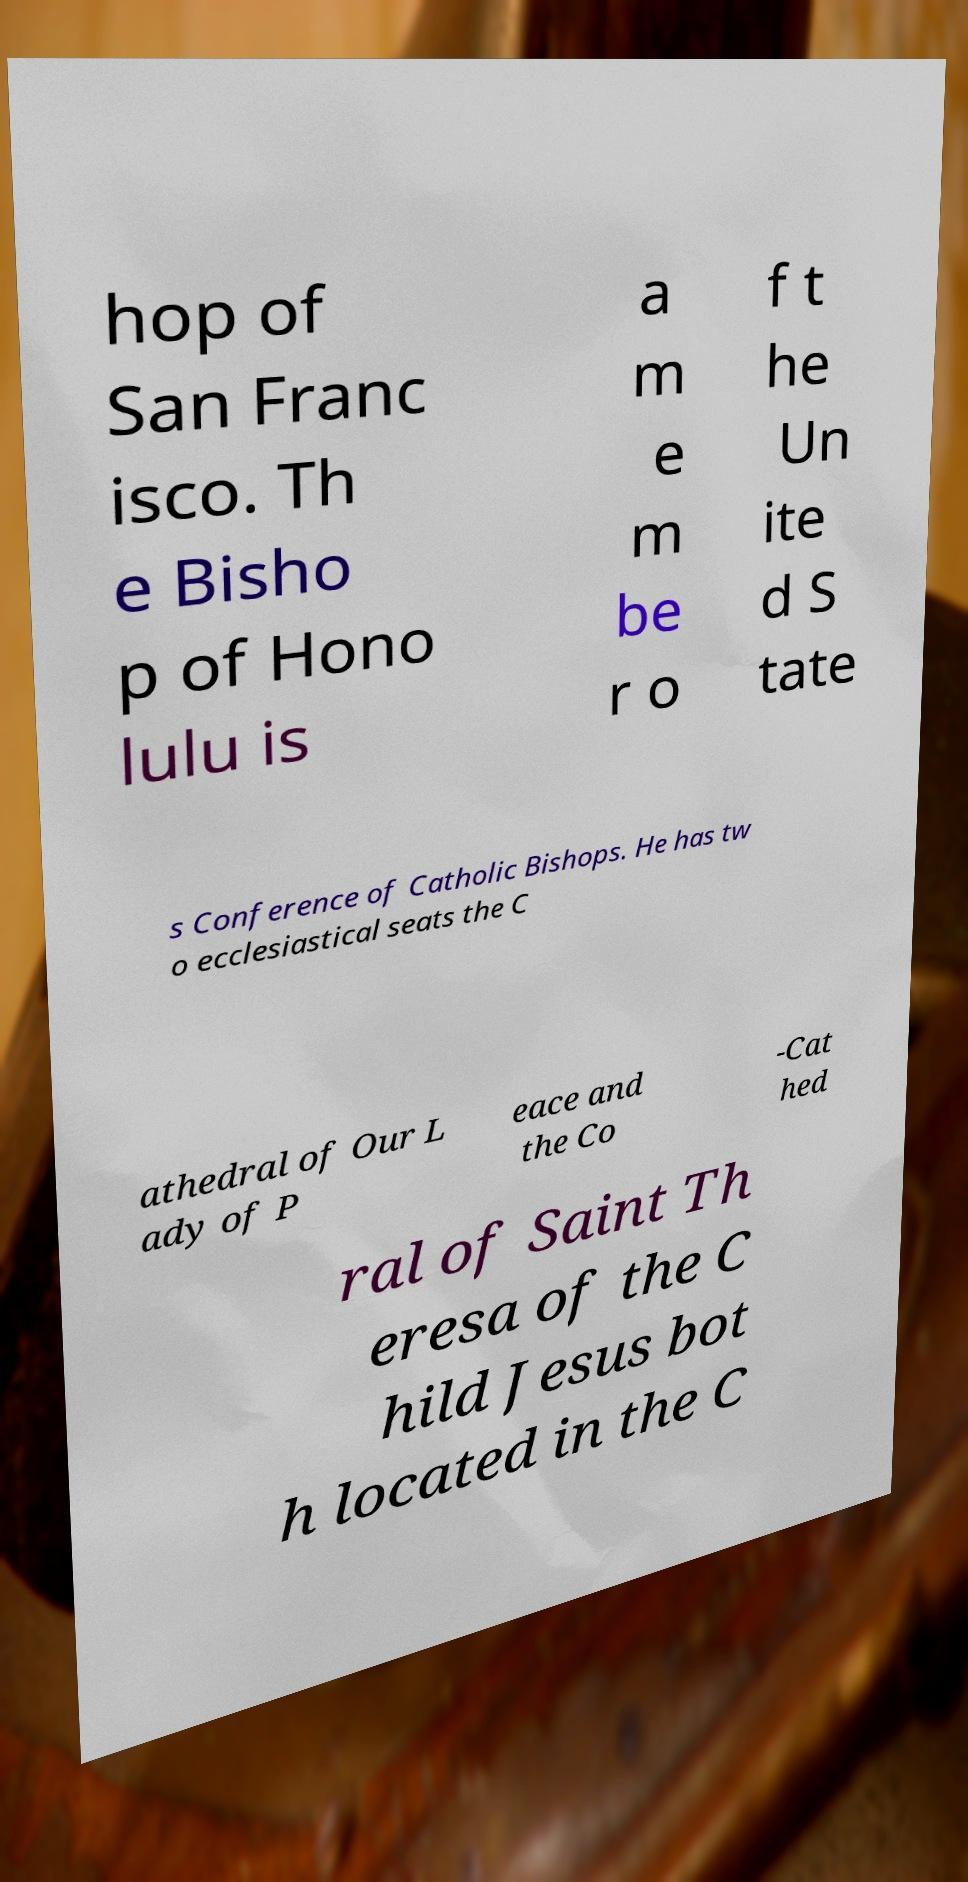Can you read and provide the text displayed in the image?This photo seems to have some interesting text. Can you extract and type it out for me? hop of San Franc isco. Th e Bisho p of Hono lulu is a m e m be r o f t he Un ite d S tate s Conference of Catholic Bishops. He has tw o ecclesiastical seats the C athedral of Our L ady of P eace and the Co -Cat hed ral of Saint Th eresa of the C hild Jesus bot h located in the C 